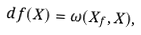Convert formula to latex. <formula><loc_0><loc_0><loc_500><loc_500>d f ( X ) = \omega ( X _ { f } , X ) ,</formula> 